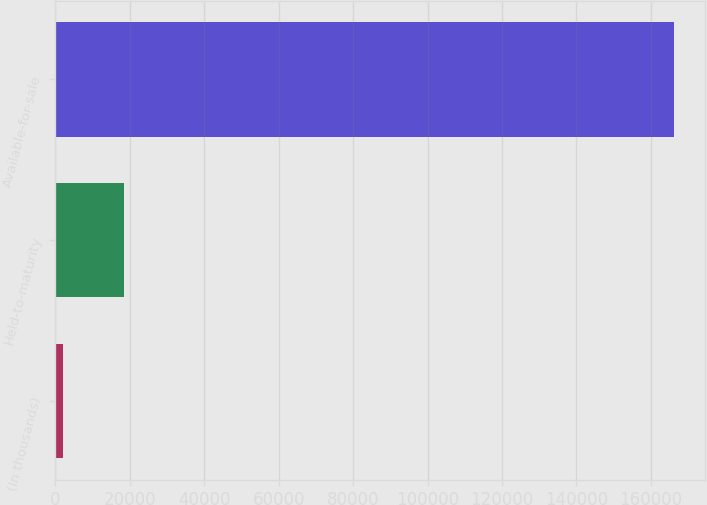<chart> <loc_0><loc_0><loc_500><loc_500><bar_chart><fcel>(In thousands)<fcel>Held-to-maturity<fcel>Available-for-sale<nl><fcel>2016<fcel>18442.5<fcel>166281<nl></chart> 